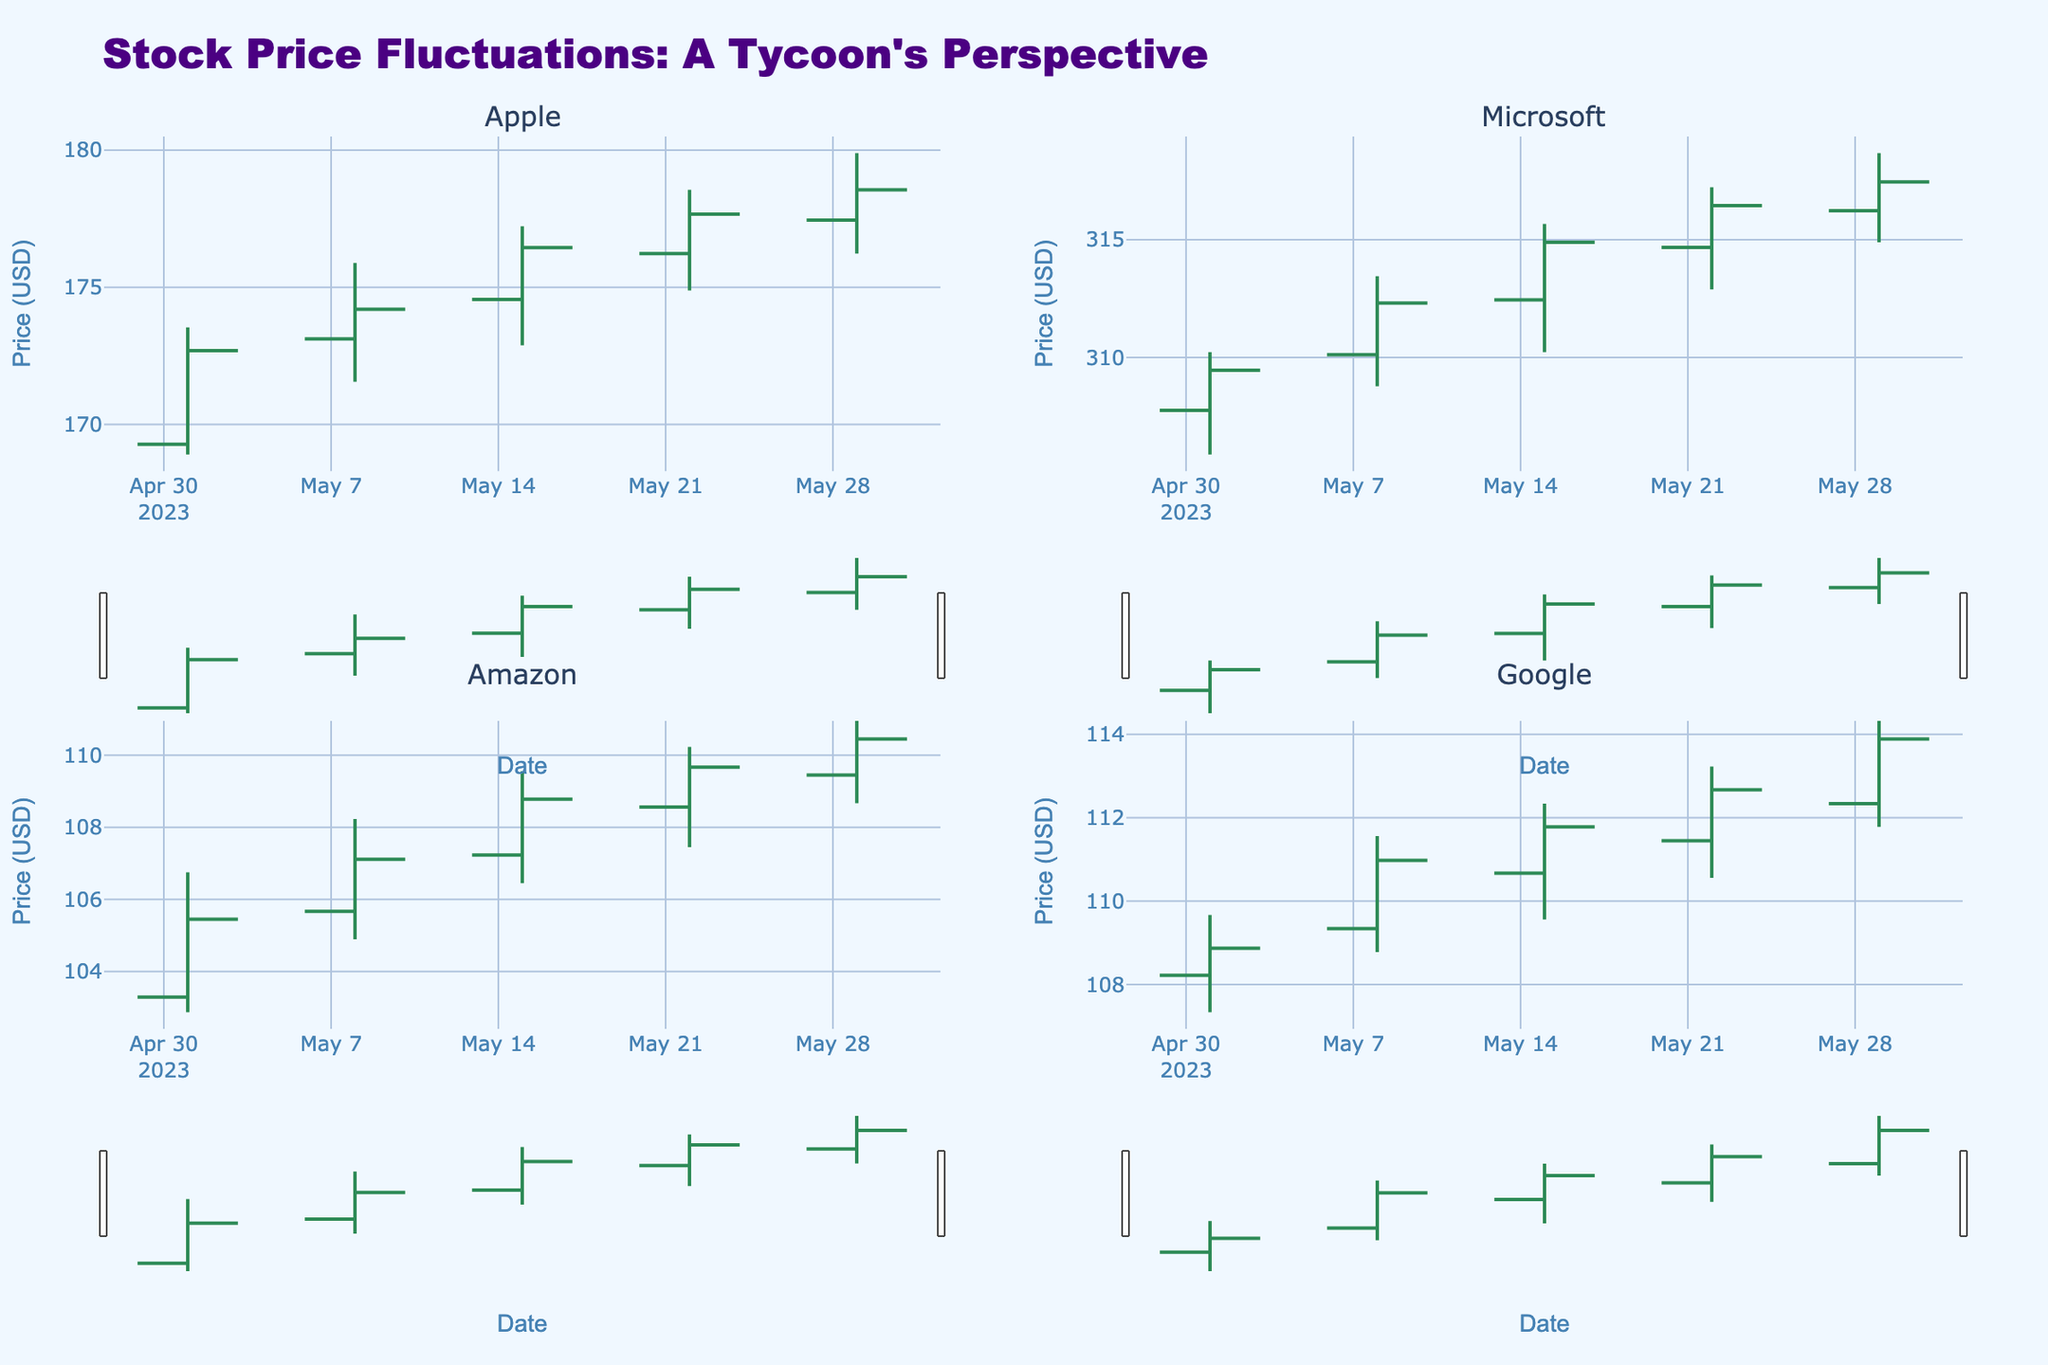What's the overall title of the chart? The overall title of the chart is likely located at the top center of the figure. By reading there, one can determine it.
Answer: Stock Price Fluctuations: A Tycoon's Perspective What are the axes' labels in the chart? The labels of the axes can be seen on the horizontal and vertical sides of each subplot. The x-axis label is "Date," and the y-axis label is "Price (USD)."
Answer: Date, Price (USD) On what date did Amazon have the highest closing price? Look at the OHLC chart for Amazon and identify the date when the closing price is at its highest point.
Answer: 2023-05-29 How does the closing price of Apple on 2023-05-15 compare to the closing price on 2023-05-08? Refer to the OHLC data for Apple on both dates and compare the closing prices. 2023-05-15 is 176.45 and 2023-05-08 is 174.20.
Answer: 176.45 is higher than 174.20 Which company's stock had the steepest increase in closing prices from May 1 to May 29? Calculate the difference between the closing prices on May 29 and May 1 for each company. Then, identify the company with the largest positive difference. Apple: 178.56 - 172.69 = 5.87, Microsoft: 317.45 - 309.46 = 7.99, Amazon: 110.45 - 105.45 = 5.00, Google: 113.89 - 108.87 = 5.02
Answer: Microsoft What is the range of Google's stock price on 2023-05-08? The range is determined by subtracting the lowest price from the highest price on that date. High (111.56) - Low (108.78)
Answer: 2.78 What is the color used for increasing lines in the OHLC chart? By examining the figure’s key or looking at increasing periods of the graph, one can see that the line for increasing prices is colored dark sea green.
Answer: Dark sea green Which company had the highest high price on 2023-05-22? Compare the high prices of all companies on this date and identify the highest one. Apple: 178.56, Microsoft: 317.23, Amazon: 110.23, Google: 113.23
Answer: Microsoft How many data points are there for each company in the chart? Each company has data points visible as they have prices for each week presented in May. Since there are dates weekly starting from May 1 to May 29, there are 5 data points per company.
Answer: 5 